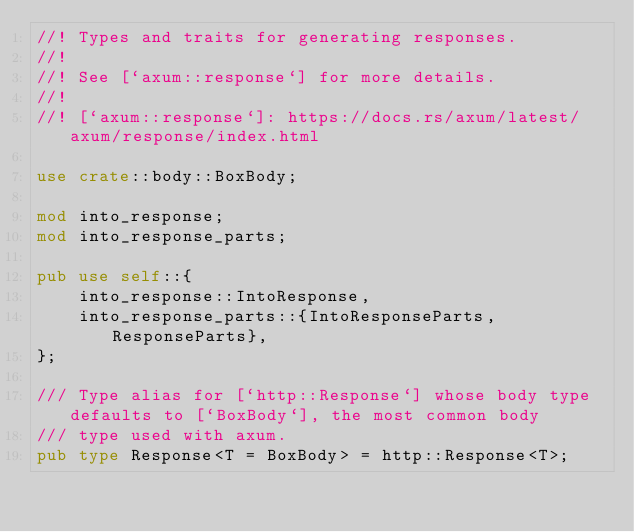<code> <loc_0><loc_0><loc_500><loc_500><_Rust_>//! Types and traits for generating responses.
//!
//! See [`axum::response`] for more details.
//!
//! [`axum::response`]: https://docs.rs/axum/latest/axum/response/index.html

use crate::body::BoxBody;

mod into_response;
mod into_response_parts;

pub use self::{
    into_response::IntoResponse,
    into_response_parts::{IntoResponseParts, ResponseParts},
};

/// Type alias for [`http::Response`] whose body type defaults to [`BoxBody`], the most common body
/// type used with axum.
pub type Response<T = BoxBody> = http::Response<T>;
</code> 